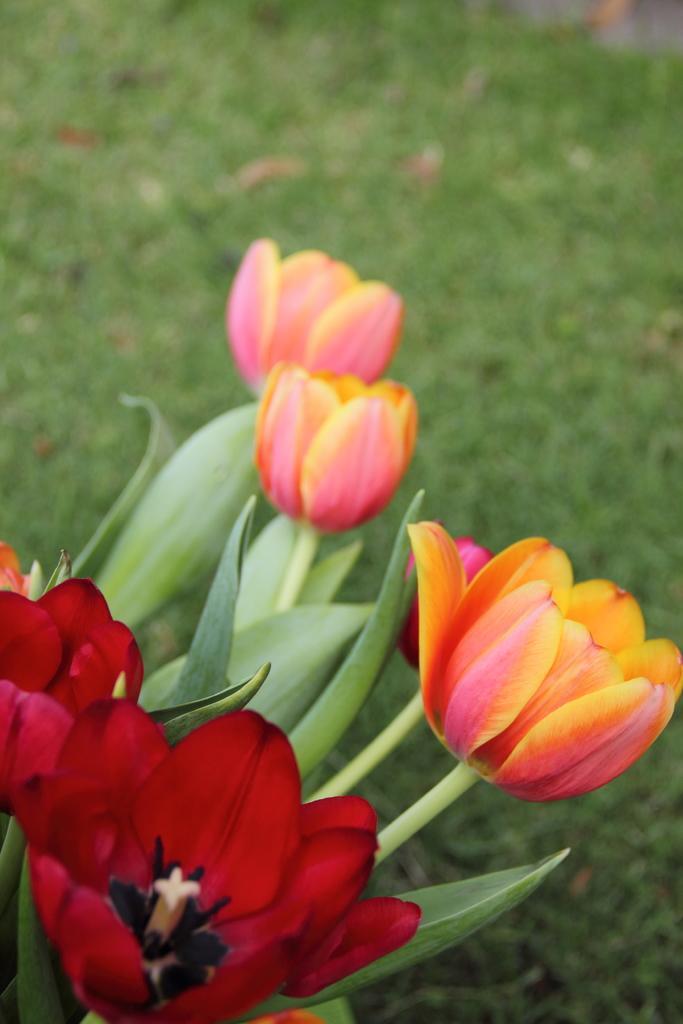Describe this image in one or two sentences. This image consists of flowers. In the front, we can see the red flowers and orange flowers. At the bottom, there is green grass on the ground. 